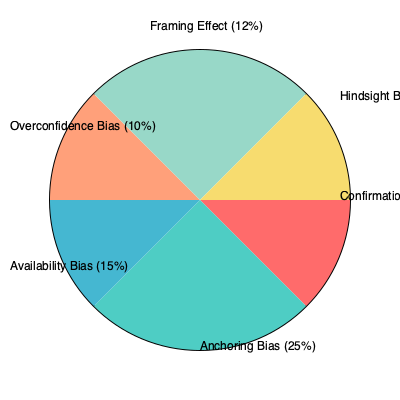As a cognitive psychology researcher, you're analyzing a pie chart depicting the distribution of different cognitive biases in decision-making. What percentage of the total biases is represented by the combination of Availability Bias and Framing Effect, and how might this inform the design of interventions to improve decision-making processes? To answer this question, we need to follow these steps:

1. Identify the percentages for Availability Bias and Framing Effect from the pie chart:
   - Availability Bias: 15%
   - Framing Effect: 12%

2. Calculate the sum of these two percentages:
   $15\% + 12\% = 27\%$

3. Interpret the result in the context of decision-making processes:
   The combination of Availability Bias and Framing Effect accounts for 27% of the total cognitive biases represented in the chart. This significant proportion suggests that these two biases play a substantial role in decision-making processes.

4. Consider implications for intervention design:
   a) Availability Bias interventions could focus on:
      - Encouraging decision-makers to seek out diverse information sources
      - Training in statistical reasoning and probability assessment
      - Implementing structured decision-making frameworks that prompt consideration of less readily available information

   b) Framing Effect interventions might include:
      - Teaching decision-makers to reframe problems from multiple perspectives
      - Developing standardized presentation formats for decision-relevant information
      - Training in recognizing and mitigating the impact of different frames on perception and judgment

   c) Combined interventions could address both biases simultaneously by:
      - Implementing comprehensive decision support systems that present information in balanced, multi-perspective formats
      - Developing training programs that enhance awareness of both biases and their interplay in decision-making
      - Encouraging organizational cultures that value thorough information gathering and diverse viewpoints in decision processes

By targeting these two biases, which together represent over a quarter of the observed biases, interventions could potentially yield significant improvements in decision-making quality and outcomes.
Answer: 27%; design interventions focusing on information sourcing, perspective-taking, and structured decision frameworks. 